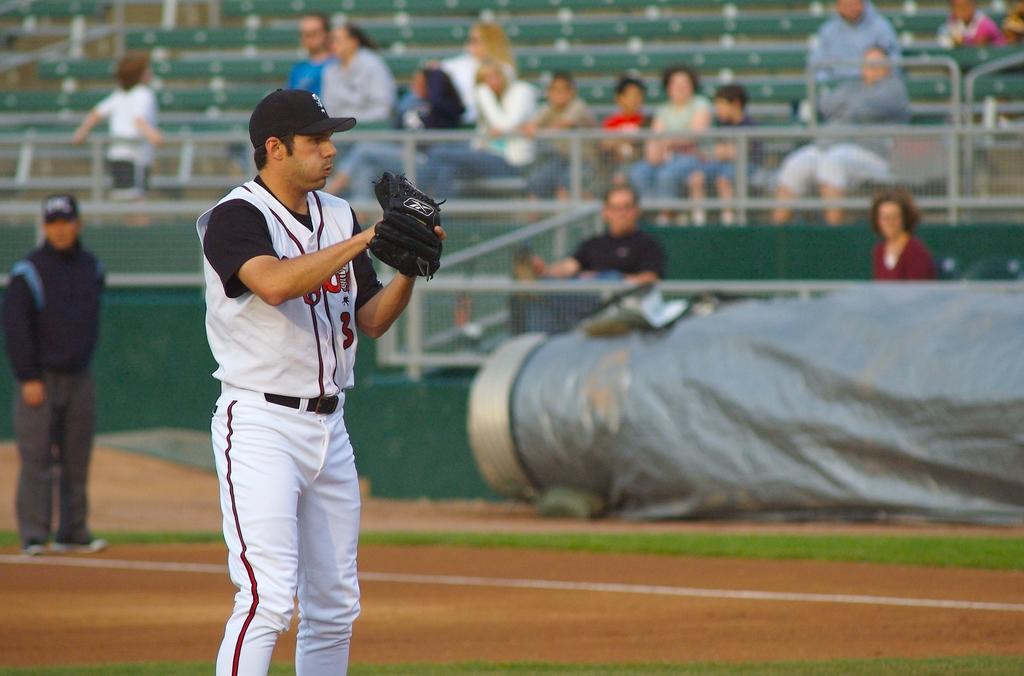Please provide a concise description of this image. Here we can see a man standing on the ground and he wore a glove. In the background we can see few people, fence, chairs, and an object. 